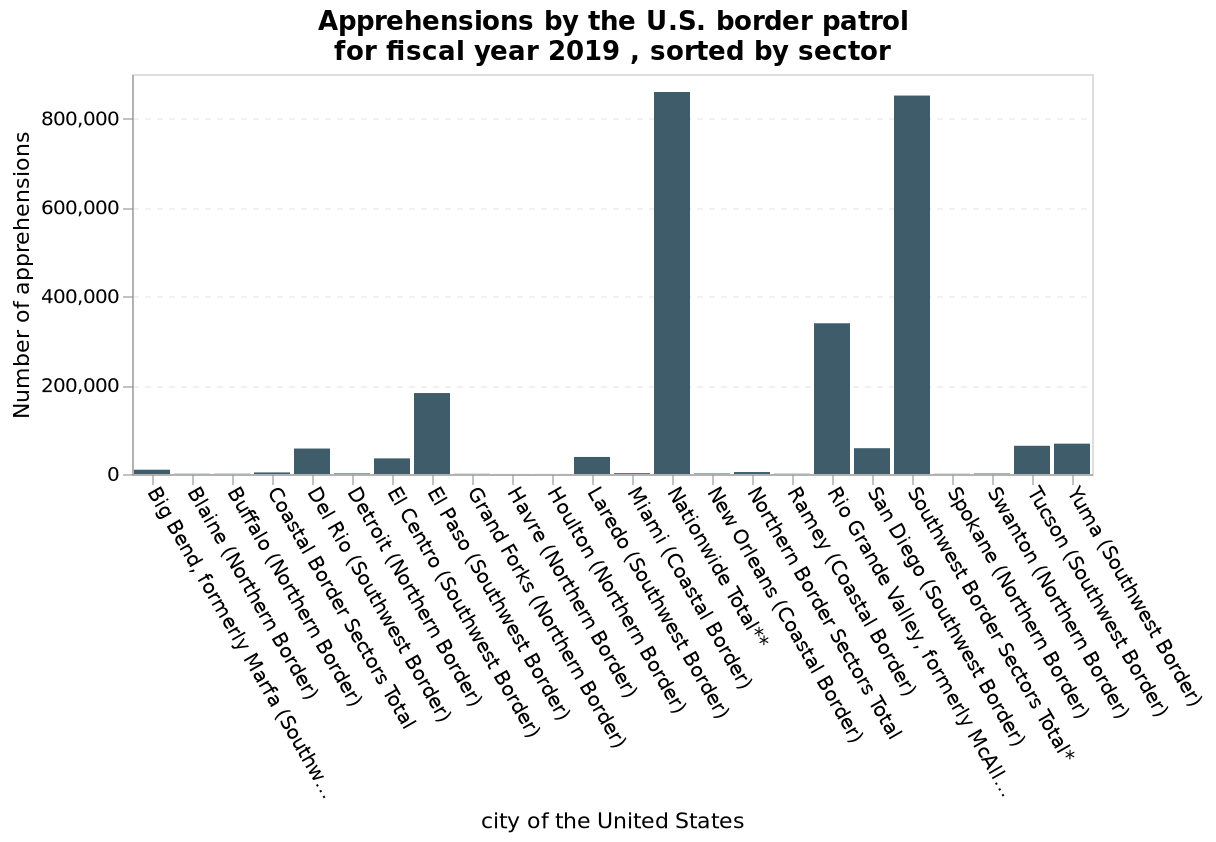<image>
Describe the following image in detail This bar diagram is labeled Apprehensions by the U.S. border patrol for fiscal year 2019 , sorted by sector. The x-axis shows city of the United States on a categorical scale from Big Bend, formerly Marfa (Southwest Border) to Yuma (Southwest Border). Number of apprehensions is plotted as a linear scale with a minimum of 0 and a maximum of 800,000 along the y-axis. Which areas, except for the Rio Grande Valley, had less than 200,000 apprehensions? All the areas except for the Rio Grande Valley had less than 200,000 apprehensions. 